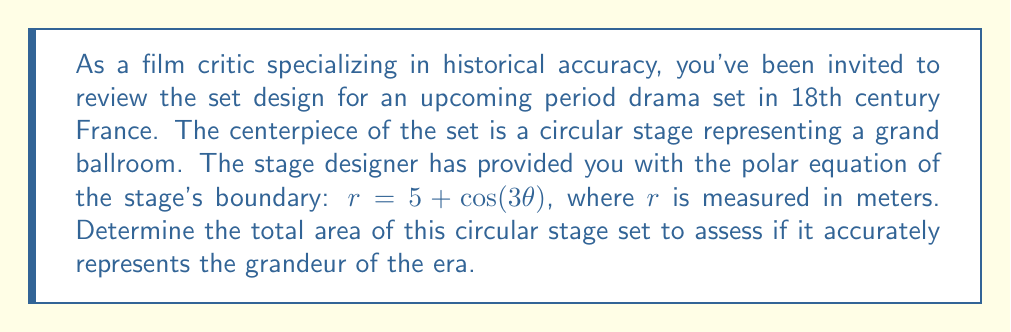Can you solve this math problem? To find the area of the stage described by the polar equation $r = 5 + \cos(3\theta)$, we need to use the formula for area in polar coordinates:

$$A = \frac{1}{2} \int_{0}^{2\pi} r^2 d\theta$$

Let's proceed step by step:

1) First, we square the given equation for $r$:
   $r^2 = (5 + \cos(3\theta))^2 = 25 + 10\cos(3\theta) + \cos^2(3\theta)$

2) We can simplify $\cos^2(3\theta)$ using the identity $\cos^2x = \frac{1 + \cos(2x)}{2}$:
   $r^2 = 25 + 10\cos(3\theta) + \frac{1 + \cos(6\theta)}{2}$

3) Simplifying further:
   $r^2 = \frac{51}{2} + 10\cos(3\theta) + \frac{1}{2}\cos(6\theta)$

4) Now we can set up our integral:
   $$A = \frac{1}{2} \int_{0}^{2\pi} (\frac{51}{2} + 10\cos(3\theta) + \frac{1}{2}\cos(6\theta)) d\theta$$

5) Let's integrate each term:
   - $\int_{0}^{2\pi} \frac{51}{2} d\theta = \frac{51}{2} \theta \big|_{0}^{2\pi} = 51\pi$
   - $\int_{0}^{2\pi} 10\cos(3\theta) d\theta = \frac{10}{3}\sin(3\theta) \big|_{0}^{2\pi} = 0$
   - $\int_{0}^{2\pi} \frac{1}{2}\cos(6\theta) d\theta = \frac{1}{12}\sin(6\theta) \big|_{0}^{2\pi} = 0$

6) Adding these results and multiplying by $\frac{1}{2}$:
   $$A = \frac{1}{2}(51\pi + 0 + 0) = \frac{51\pi}{2}$$

Therefore, the area of the circular stage is $\frac{51\pi}{2}$ square meters.
Answer: $$A = \frac{51\pi}{2} \approx 80.11 \text{ square meters}$$ 